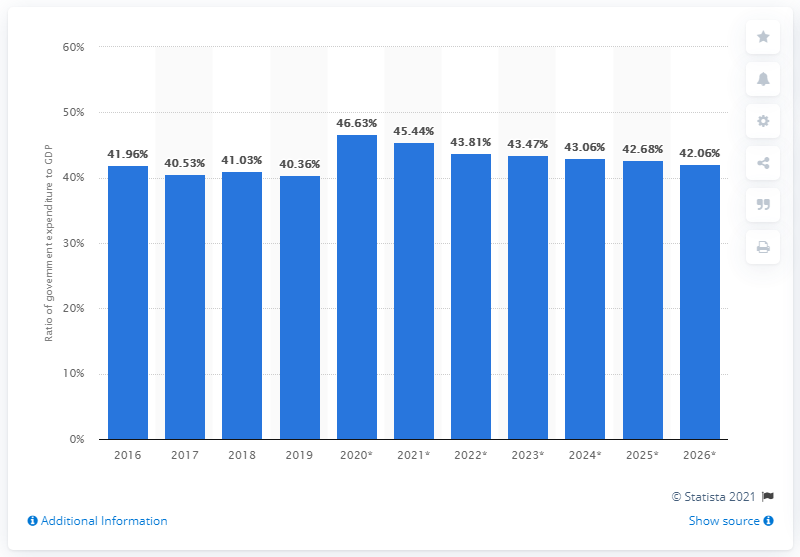Point out several critical features in this image. In 2019, the government's expenditure accounted for 40.36% of the country's Gross Domestic Product (GDP). 